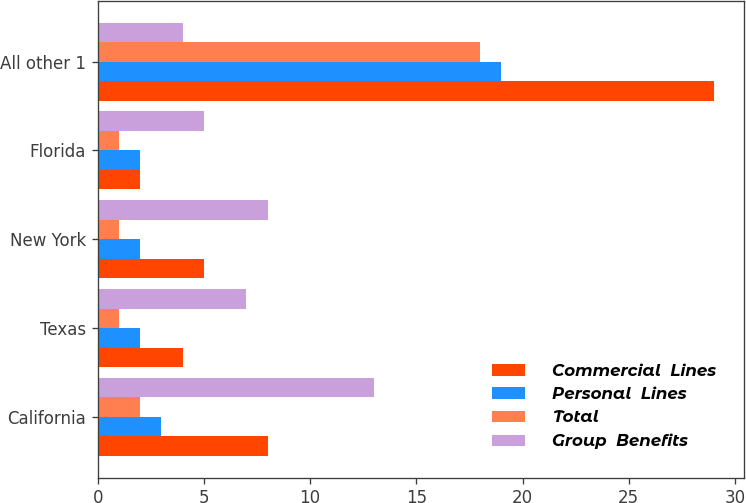Convert chart to OTSL. <chart><loc_0><loc_0><loc_500><loc_500><stacked_bar_chart><ecel><fcel>California<fcel>Texas<fcel>New York<fcel>Florida<fcel>All other 1<nl><fcel>Commercial  Lines<fcel>8<fcel>4<fcel>5<fcel>2<fcel>29<nl><fcel>Personal  Lines<fcel>3<fcel>2<fcel>2<fcel>2<fcel>19<nl><fcel>Total<fcel>2<fcel>1<fcel>1<fcel>1<fcel>18<nl><fcel>Group  Benefits<fcel>13<fcel>7<fcel>8<fcel>5<fcel>4<nl></chart> 